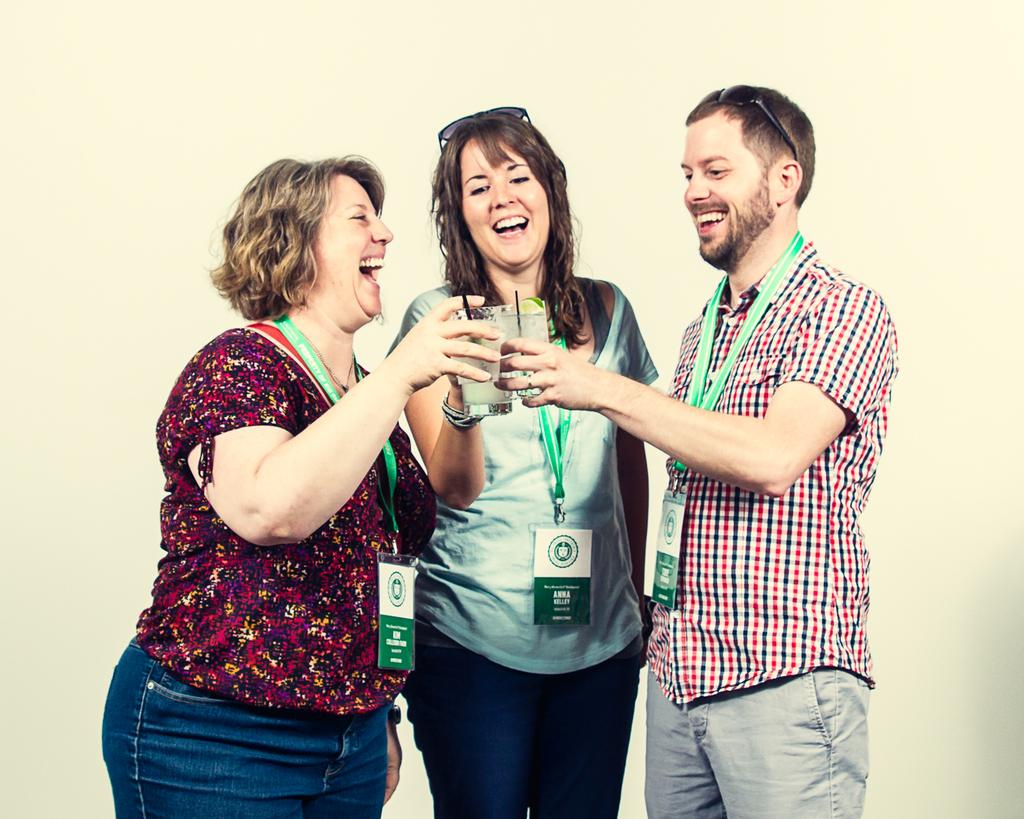How many people are in the image? There are three people in the image. What are the people wearing? The people are wearing cards. What are the people holding? The people are holding glasses. What expressions do the people have? The people are smiling. Which people are wearing sunglasses? The middle person and the right person are wearing sunglasses. What type of pie is being shared among the people in the image? There is no pie present in the image; the people are holding glasses. 